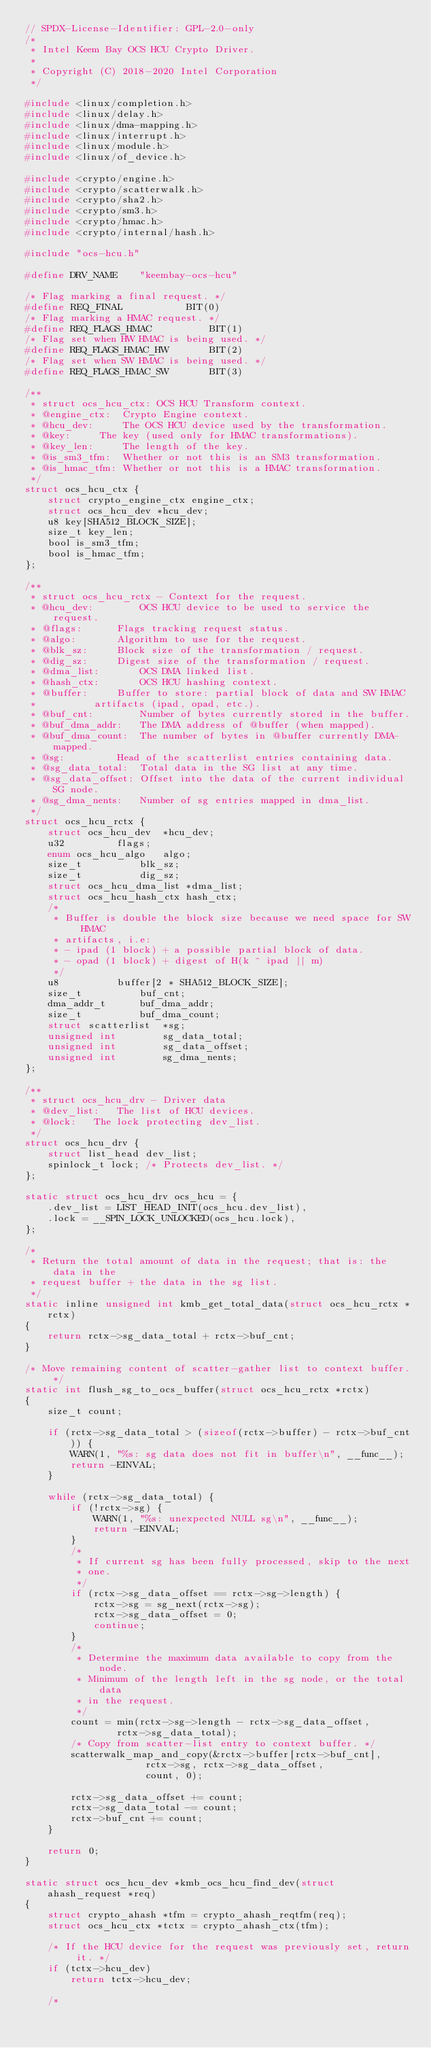Convert code to text. <code><loc_0><loc_0><loc_500><loc_500><_C_>// SPDX-License-Identifier: GPL-2.0-only
/*
 * Intel Keem Bay OCS HCU Crypto Driver.
 *
 * Copyright (C) 2018-2020 Intel Corporation
 */

#include <linux/completion.h>
#include <linux/delay.h>
#include <linux/dma-mapping.h>
#include <linux/interrupt.h>
#include <linux/module.h>
#include <linux/of_device.h>

#include <crypto/engine.h>
#include <crypto/scatterwalk.h>
#include <crypto/sha2.h>
#include <crypto/sm3.h>
#include <crypto/hmac.h>
#include <crypto/internal/hash.h>

#include "ocs-hcu.h"

#define DRV_NAME	"keembay-ocs-hcu"

/* Flag marking a final request. */
#define REQ_FINAL			BIT(0)
/* Flag marking a HMAC request. */
#define REQ_FLAGS_HMAC			BIT(1)
/* Flag set when HW HMAC is being used. */
#define REQ_FLAGS_HMAC_HW		BIT(2)
/* Flag set when SW HMAC is being used. */
#define REQ_FLAGS_HMAC_SW		BIT(3)

/**
 * struct ocs_hcu_ctx: OCS HCU Transform context.
 * @engine_ctx:	 Crypto Engine context.
 * @hcu_dev:	 The OCS HCU device used by the transformation.
 * @key:	 The key (used only for HMAC transformations).
 * @key_len:	 The length of the key.
 * @is_sm3_tfm:  Whether or not this is an SM3 transformation.
 * @is_hmac_tfm: Whether or not this is a HMAC transformation.
 */
struct ocs_hcu_ctx {
	struct crypto_engine_ctx engine_ctx;
	struct ocs_hcu_dev *hcu_dev;
	u8 key[SHA512_BLOCK_SIZE];
	size_t key_len;
	bool is_sm3_tfm;
	bool is_hmac_tfm;
};

/**
 * struct ocs_hcu_rctx - Context for the request.
 * @hcu_dev:	    OCS HCU device to be used to service the request.
 * @flags:	    Flags tracking request status.
 * @algo:	    Algorithm to use for the request.
 * @blk_sz:	    Block size of the transformation / request.
 * @dig_sz:	    Digest size of the transformation / request.
 * @dma_list:	    OCS DMA linked list.
 * @hash_ctx:	    OCS HCU hashing context.
 * @buffer:	    Buffer to store: partial block of data and SW HMAC
 *		    artifacts (ipad, opad, etc.).
 * @buf_cnt:	    Number of bytes currently stored in the buffer.
 * @buf_dma_addr:   The DMA address of @buffer (when mapped).
 * @buf_dma_count:  The number of bytes in @buffer currently DMA-mapped.
 * @sg:		    Head of the scatterlist entries containing data.
 * @sg_data_total:  Total data in the SG list at any time.
 * @sg_data_offset: Offset into the data of the current individual SG node.
 * @sg_dma_nents:   Number of sg entries mapped in dma_list.
 */
struct ocs_hcu_rctx {
	struct ocs_hcu_dev	*hcu_dev;
	u32			flags;
	enum ocs_hcu_algo	algo;
	size_t			blk_sz;
	size_t			dig_sz;
	struct ocs_hcu_dma_list	*dma_list;
	struct ocs_hcu_hash_ctx	hash_ctx;
	/*
	 * Buffer is double the block size because we need space for SW HMAC
	 * artifacts, i.e:
	 * - ipad (1 block) + a possible partial block of data.
	 * - opad (1 block) + digest of H(k ^ ipad || m)
	 */
	u8			buffer[2 * SHA512_BLOCK_SIZE];
	size_t			buf_cnt;
	dma_addr_t		buf_dma_addr;
	size_t			buf_dma_count;
	struct scatterlist	*sg;
	unsigned int		sg_data_total;
	unsigned int		sg_data_offset;
	unsigned int		sg_dma_nents;
};

/**
 * struct ocs_hcu_drv - Driver data
 * @dev_list:	The list of HCU devices.
 * @lock:	The lock protecting dev_list.
 */
struct ocs_hcu_drv {
	struct list_head dev_list;
	spinlock_t lock; /* Protects dev_list. */
};

static struct ocs_hcu_drv ocs_hcu = {
	.dev_list = LIST_HEAD_INIT(ocs_hcu.dev_list),
	.lock = __SPIN_LOCK_UNLOCKED(ocs_hcu.lock),
};

/*
 * Return the total amount of data in the request; that is: the data in the
 * request buffer + the data in the sg list.
 */
static inline unsigned int kmb_get_total_data(struct ocs_hcu_rctx *rctx)
{
	return rctx->sg_data_total + rctx->buf_cnt;
}

/* Move remaining content of scatter-gather list to context buffer. */
static int flush_sg_to_ocs_buffer(struct ocs_hcu_rctx *rctx)
{
	size_t count;

	if (rctx->sg_data_total > (sizeof(rctx->buffer) - rctx->buf_cnt)) {
		WARN(1, "%s: sg data does not fit in buffer\n", __func__);
		return -EINVAL;
	}

	while (rctx->sg_data_total) {
		if (!rctx->sg) {
			WARN(1, "%s: unexpected NULL sg\n", __func__);
			return -EINVAL;
		}
		/*
		 * If current sg has been fully processed, skip to the next
		 * one.
		 */
		if (rctx->sg_data_offset == rctx->sg->length) {
			rctx->sg = sg_next(rctx->sg);
			rctx->sg_data_offset = 0;
			continue;
		}
		/*
		 * Determine the maximum data available to copy from the node.
		 * Minimum of the length left in the sg node, or the total data
		 * in the request.
		 */
		count = min(rctx->sg->length - rctx->sg_data_offset,
			    rctx->sg_data_total);
		/* Copy from scatter-list entry to context buffer. */
		scatterwalk_map_and_copy(&rctx->buffer[rctx->buf_cnt],
					 rctx->sg, rctx->sg_data_offset,
					 count, 0);

		rctx->sg_data_offset += count;
		rctx->sg_data_total -= count;
		rctx->buf_cnt += count;
	}

	return 0;
}

static struct ocs_hcu_dev *kmb_ocs_hcu_find_dev(struct ahash_request *req)
{
	struct crypto_ahash *tfm = crypto_ahash_reqtfm(req);
	struct ocs_hcu_ctx *tctx = crypto_ahash_ctx(tfm);

	/* If the HCU device for the request was previously set, return it. */
	if (tctx->hcu_dev)
		return tctx->hcu_dev;

	/*</code> 